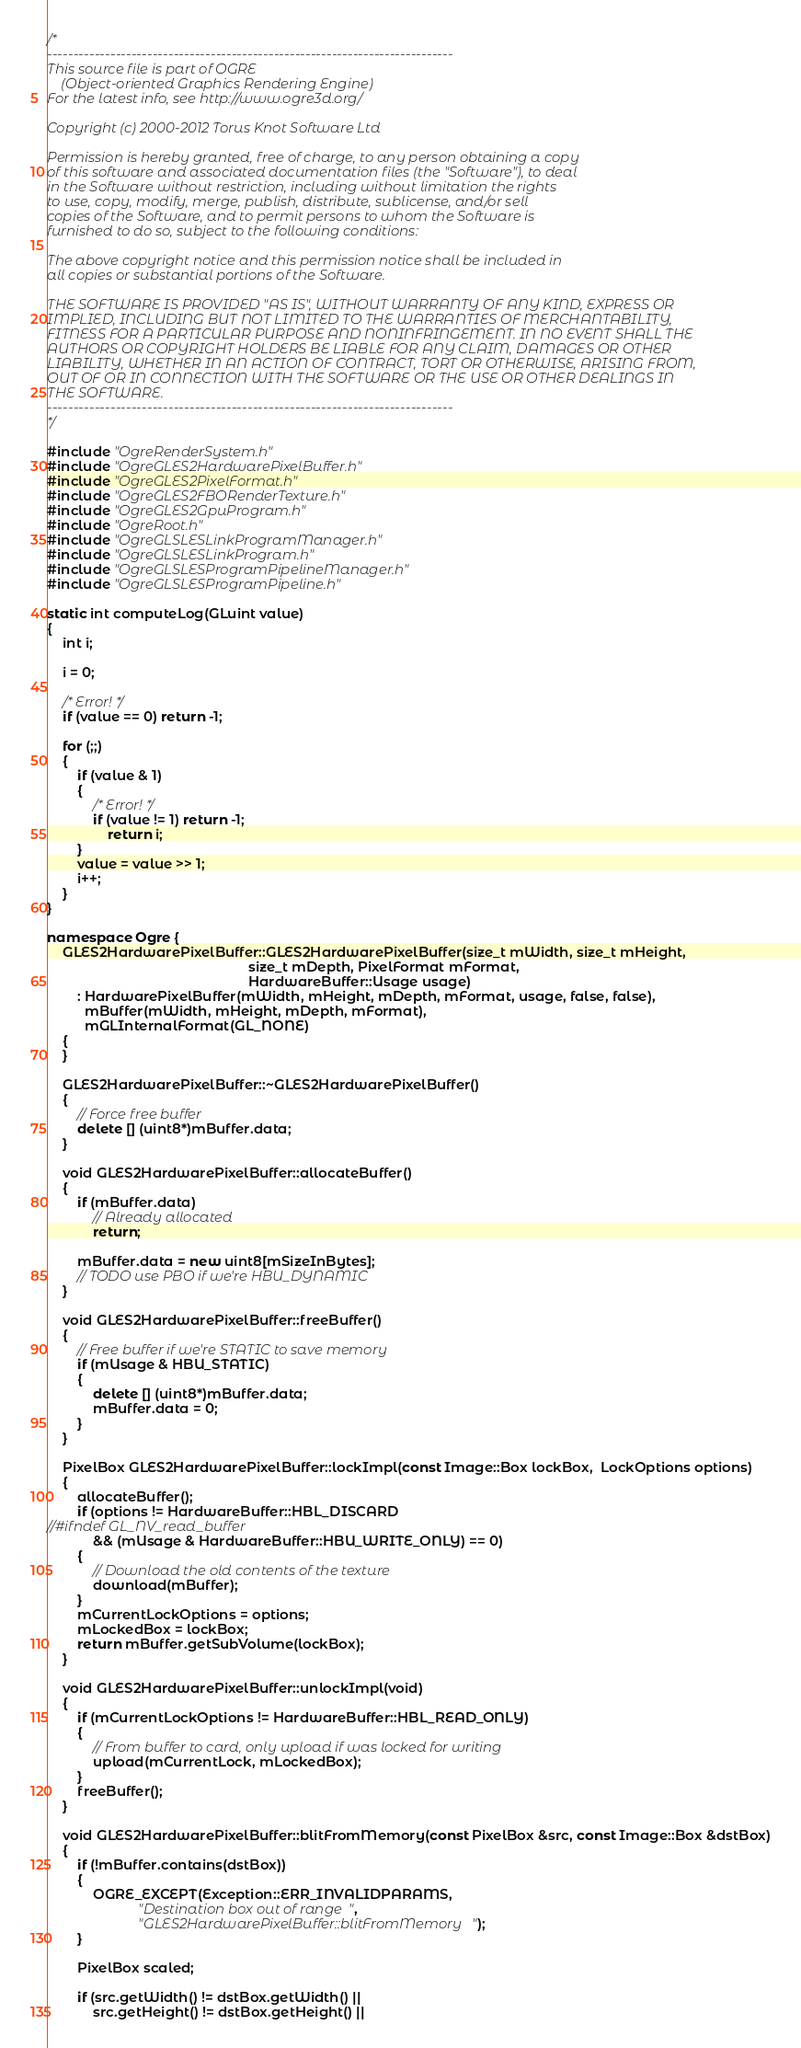Convert code to text. <code><loc_0><loc_0><loc_500><loc_500><_C++_>/*
-----------------------------------------------------------------------------
This source file is part of OGRE
    (Object-oriented Graphics Rendering Engine)
For the latest info, see http://www.ogre3d.org/

Copyright (c) 2000-2012 Torus Knot Software Ltd

Permission is hereby granted, free of charge, to any person obtaining a copy
of this software and associated documentation files (the "Software"), to deal
in the Software without restriction, including without limitation the rights
to use, copy, modify, merge, publish, distribute, sublicense, and/or sell
copies of the Software, and to permit persons to whom the Software is
furnished to do so, subject to the following conditions:

The above copyright notice and this permission notice shall be included in
all copies or substantial portions of the Software.

THE SOFTWARE IS PROVIDED "AS IS", WITHOUT WARRANTY OF ANY KIND, EXPRESS OR
IMPLIED, INCLUDING BUT NOT LIMITED TO THE WARRANTIES OF MERCHANTABILITY,
FITNESS FOR A PARTICULAR PURPOSE AND NONINFRINGEMENT. IN NO EVENT SHALL THE
AUTHORS OR COPYRIGHT HOLDERS BE LIABLE FOR ANY CLAIM, DAMAGES OR OTHER
LIABILITY, WHETHER IN AN ACTION OF CONTRACT, TORT OR OTHERWISE, ARISING FROM,
OUT OF OR IN CONNECTION WITH THE SOFTWARE OR THE USE OR OTHER DEALINGS IN
THE SOFTWARE.
-----------------------------------------------------------------------------
*/

#include "OgreRenderSystem.h"
#include "OgreGLES2HardwarePixelBuffer.h"
#include "OgreGLES2PixelFormat.h"
#include "OgreGLES2FBORenderTexture.h"
#include "OgreGLES2GpuProgram.h"
#include "OgreRoot.h"
#include "OgreGLSLESLinkProgramManager.h"
#include "OgreGLSLESLinkProgram.h"
#include "OgreGLSLESProgramPipelineManager.h"
#include "OgreGLSLESProgramPipeline.h"

static int computeLog(GLuint value)
{
    int i;

    i = 0;

    /* Error! */
    if (value == 0) return -1;

    for (;;)
    {
        if (value & 1)
        {
            /* Error! */
            if (value != 1) return -1;
                return i;
        }
        value = value >> 1;
        i++;
    }
}

namespace Ogre {
    GLES2HardwarePixelBuffer::GLES2HardwarePixelBuffer(size_t mWidth, size_t mHeight,
                                                     size_t mDepth, PixelFormat mFormat,
                                                     HardwareBuffer::Usage usage)
        : HardwarePixelBuffer(mWidth, mHeight, mDepth, mFormat, usage, false, false),
          mBuffer(mWidth, mHeight, mDepth, mFormat),
          mGLInternalFormat(GL_NONE)
    {
    }

    GLES2HardwarePixelBuffer::~GLES2HardwarePixelBuffer()
    {
        // Force free buffer
        delete [] (uint8*)mBuffer.data;
    }

    void GLES2HardwarePixelBuffer::allocateBuffer()
    {
        if (mBuffer.data)
            // Already allocated
            return;

        mBuffer.data = new uint8[mSizeInBytes];
        // TODO use PBO if we're HBU_DYNAMIC
    }

    void GLES2HardwarePixelBuffer::freeBuffer()
    {
        // Free buffer if we're STATIC to save memory
        if (mUsage & HBU_STATIC)
        {
            delete [] (uint8*)mBuffer.data;
            mBuffer.data = 0;
        }
    }

    PixelBox GLES2HardwarePixelBuffer::lockImpl(const Image::Box lockBox,  LockOptions options)
    {
        allocateBuffer();
        if (options != HardwareBuffer::HBL_DISCARD
//#ifndef GL_NV_read_buffer
            && (mUsage & HardwareBuffer::HBU_WRITE_ONLY) == 0)
        {
            // Download the old contents of the texture
            download(mBuffer);
        }
        mCurrentLockOptions = options;
        mLockedBox = lockBox;
        return mBuffer.getSubVolume(lockBox);
    }

    void GLES2HardwarePixelBuffer::unlockImpl(void)
    {
        if (mCurrentLockOptions != HardwareBuffer::HBL_READ_ONLY)
        {
            // From buffer to card, only upload if was locked for writing
            upload(mCurrentLock, mLockedBox);
        }
        freeBuffer();
    }

    void GLES2HardwarePixelBuffer::blitFromMemory(const PixelBox &src, const Image::Box &dstBox)
    {
        if (!mBuffer.contains(dstBox))
        {
            OGRE_EXCEPT(Exception::ERR_INVALIDPARAMS,
                        "Destination box out of range",
                        "GLES2HardwarePixelBuffer::blitFromMemory");
        }

        PixelBox scaled;

        if (src.getWidth() != dstBox.getWidth() ||
            src.getHeight() != dstBox.getHeight() ||</code> 